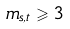Convert formula to latex. <formula><loc_0><loc_0><loc_500><loc_500>m _ { s , t } \geqslant 3</formula> 